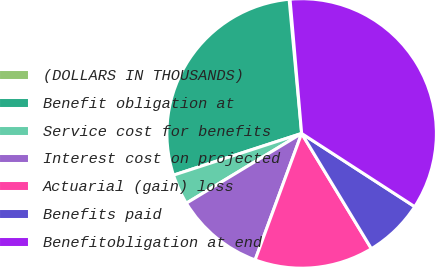<chart> <loc_0><loc_0><loc_500><loc_500><pie_chart><fcel>(DOLLARS IN THOUSANDS)<fcel>Benefit obligation at<fcel>Service cost for benefits<fcel>Interest cost on projected<fcel>Actuarial (gain) loss<fcel>Benefits paid<fcel>Benefitobligation at end<nl><fcel>0.11%<fcel>28.52%<fcel>3.65%<fcel>10.73%<fcel>14.27%<fcel>7.19%<fcel>35.51%<nl></chart> 